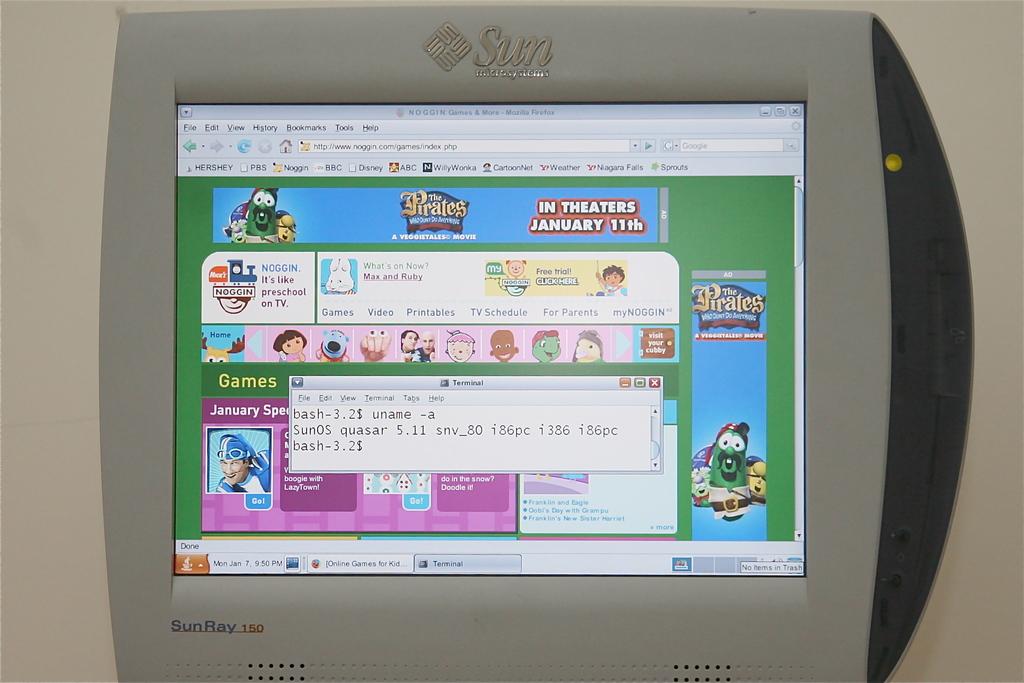When is this movie in theaters?
Offer a terse response. January 11th. What does the text on the bottom say?
Offer a terse response. Sunray. 